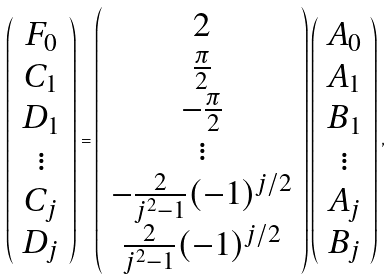<formula> <loc_0><loc_0><loc_500><loc_500>\left ( \begin{array} { c } F _ { 0 } \\ C _ { 1 } \\ D _ { 1 } \\ \vdots \\ C _ { j } \\ D _ { j } \end{array} \right ) = \left ( \begin{array} { c } 2 \\ \frac { \pi } { 2 } \\ - \frac { \pi } { 2 } \\ \vdots \\ - \frac { 2 } { j ^ { 2 } - 1 } ( - 1 ) ^ { j / 2 } \\ \frac { 2 } { j ^ { 2 } - 1 } ( - 1 ) ^ { j / 2 } \end{array} \right ) \left ( \begin{array} { c } A _ { 0 } \\ A _ { 1 } \\ B _ { 1 } \\ \vdots \\ A _ { j } \\ B _ { j } \end{array} \right ) ,</formula> 